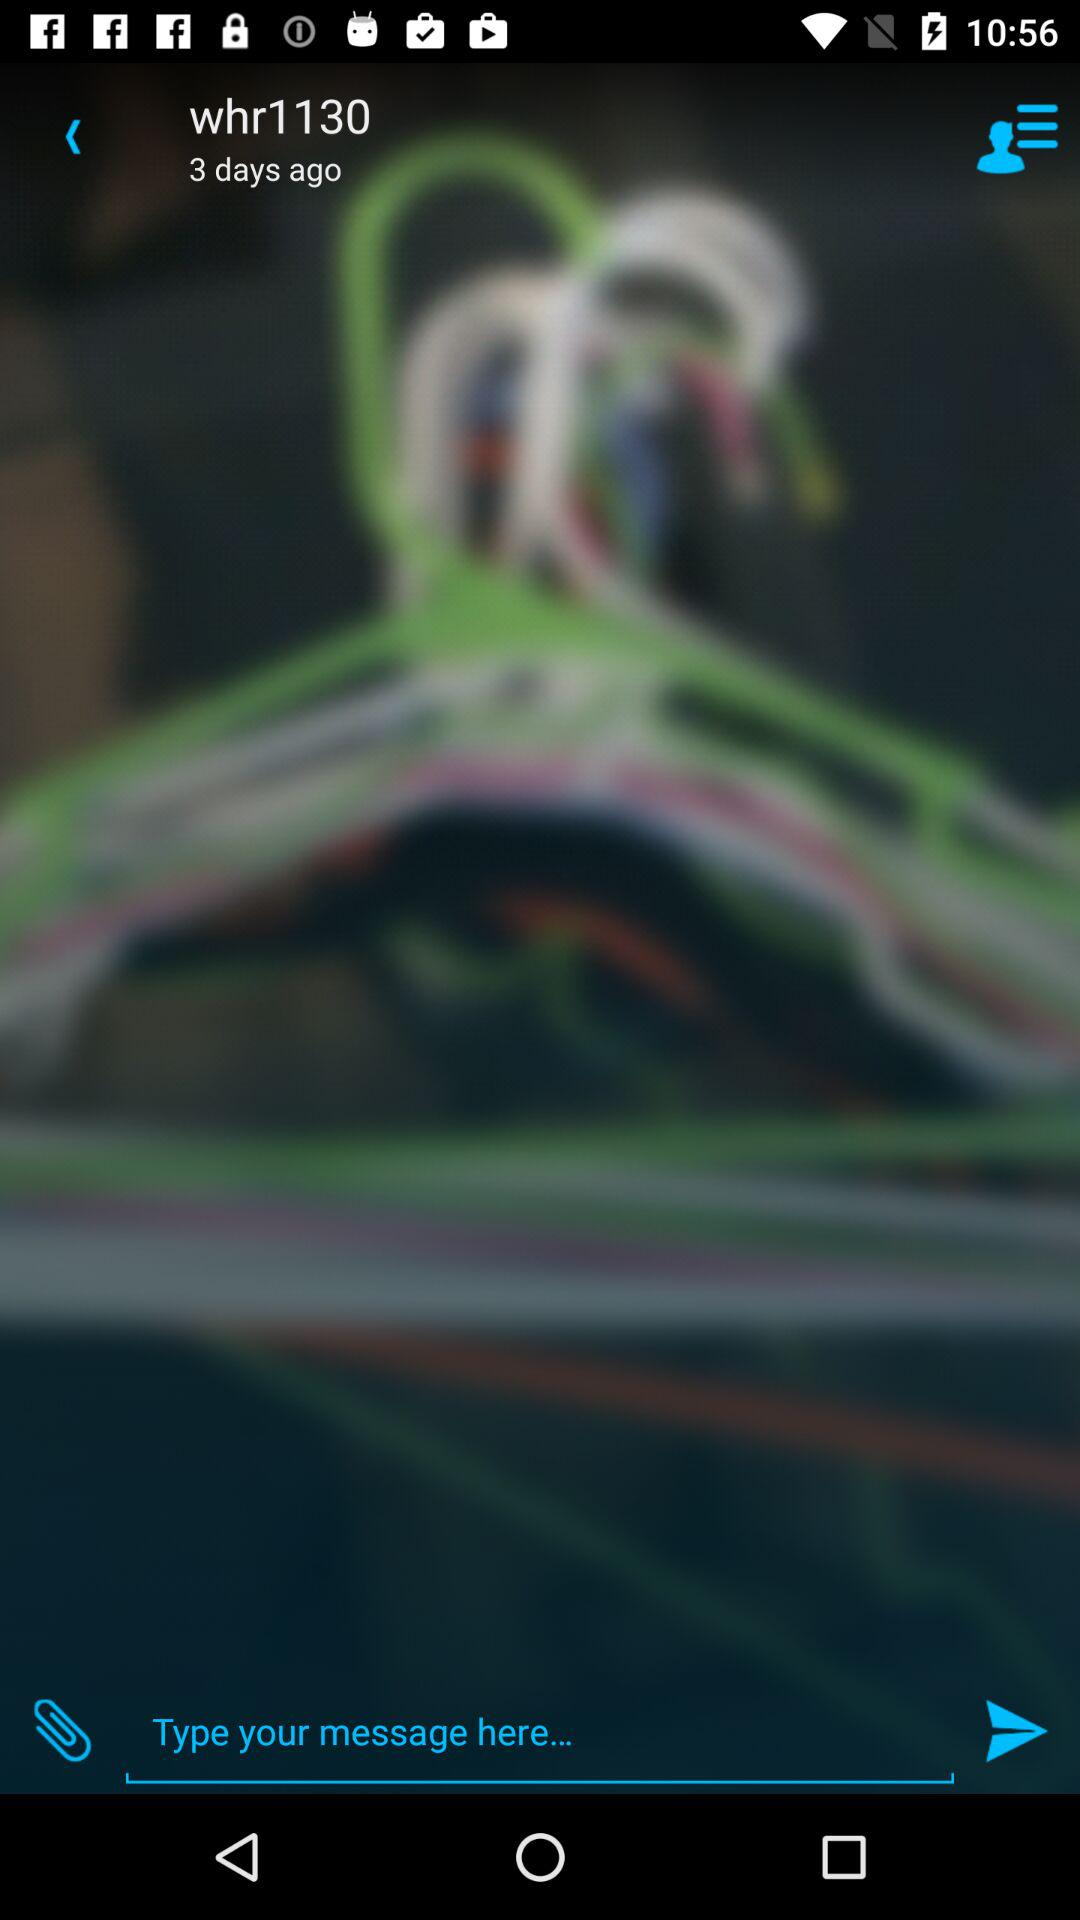After how many days ago whr1130 messaged?
When the provided information is insufficient, respond with <no answer>. <no answer> 